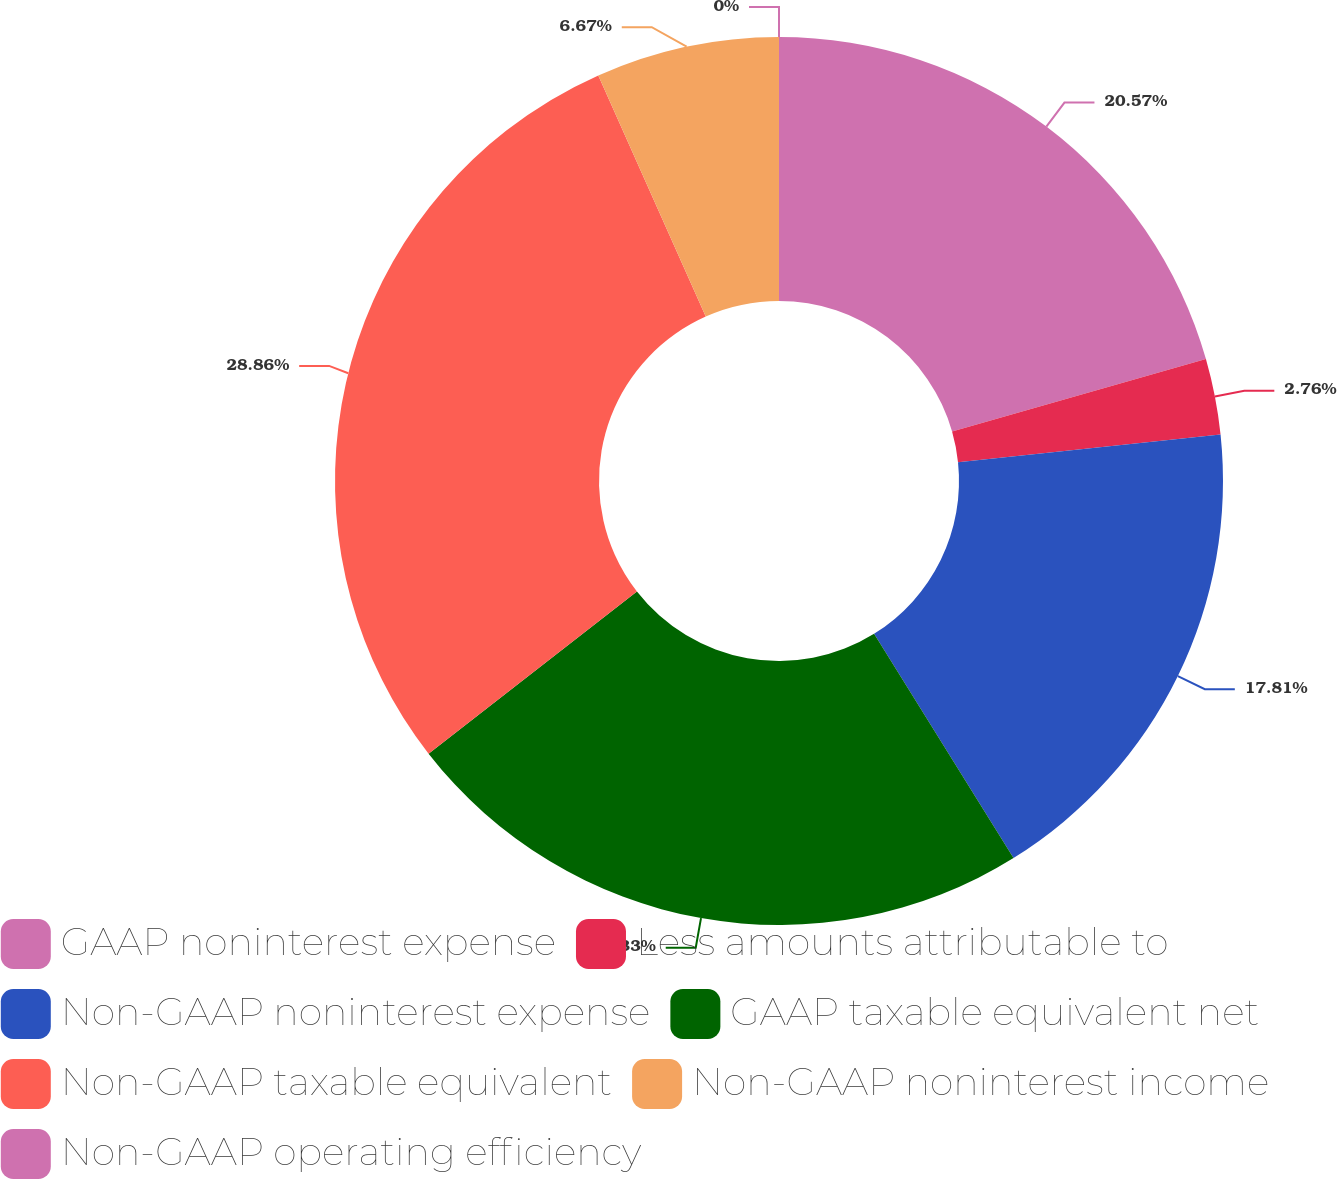Convert chart to OTSL. <chart><loc_0><loc_0><loc_500><loc_500><pie_chart><fcel>GAAP noninterest expense<fcel>Less amounts attributable to<fcel>Non-GAAP noninterest expense<fcel>GAAP taxable equivalent net<fcel>Non-GAAP taxable equivalent<fcel>Non-GAAP noninterest income<fcel>Non-GAAP operating efficiency<nl><fcel>20.57%<fcel>2.76%<fcel>17.81%<fcel>23.33%<fcel>28.85%<fcel>6.67%<fcel>0.0%<nl></chart> 